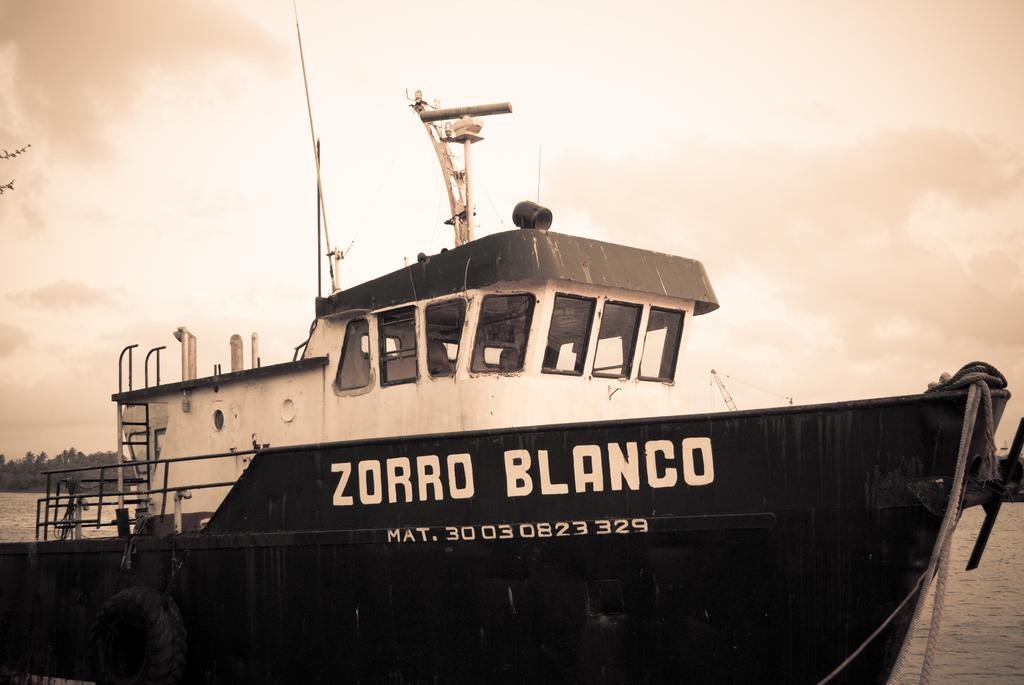What is the main subject of the image? The main subject of the image is a ship. Can you describe the ship's position in relation to the water? The ship is above the water in the image. What can be seen in the background of the image? There are trees visible behind the ship, and clouds can be seen in the sky. What part of the natural environment is visible in the image? The sky is visible in the image, along with the trees and clouds. What type of ornament is hanging from the ship's mast in the image? There is no ornament hanging from the ship's mast in the image; it only shows the ship above the water with trees and clouds in the background. How many fowl can be seen flying near the ship in the image? There are no fowl visible in the image; it only shows the ship above the water with trees and clouds in the background. 